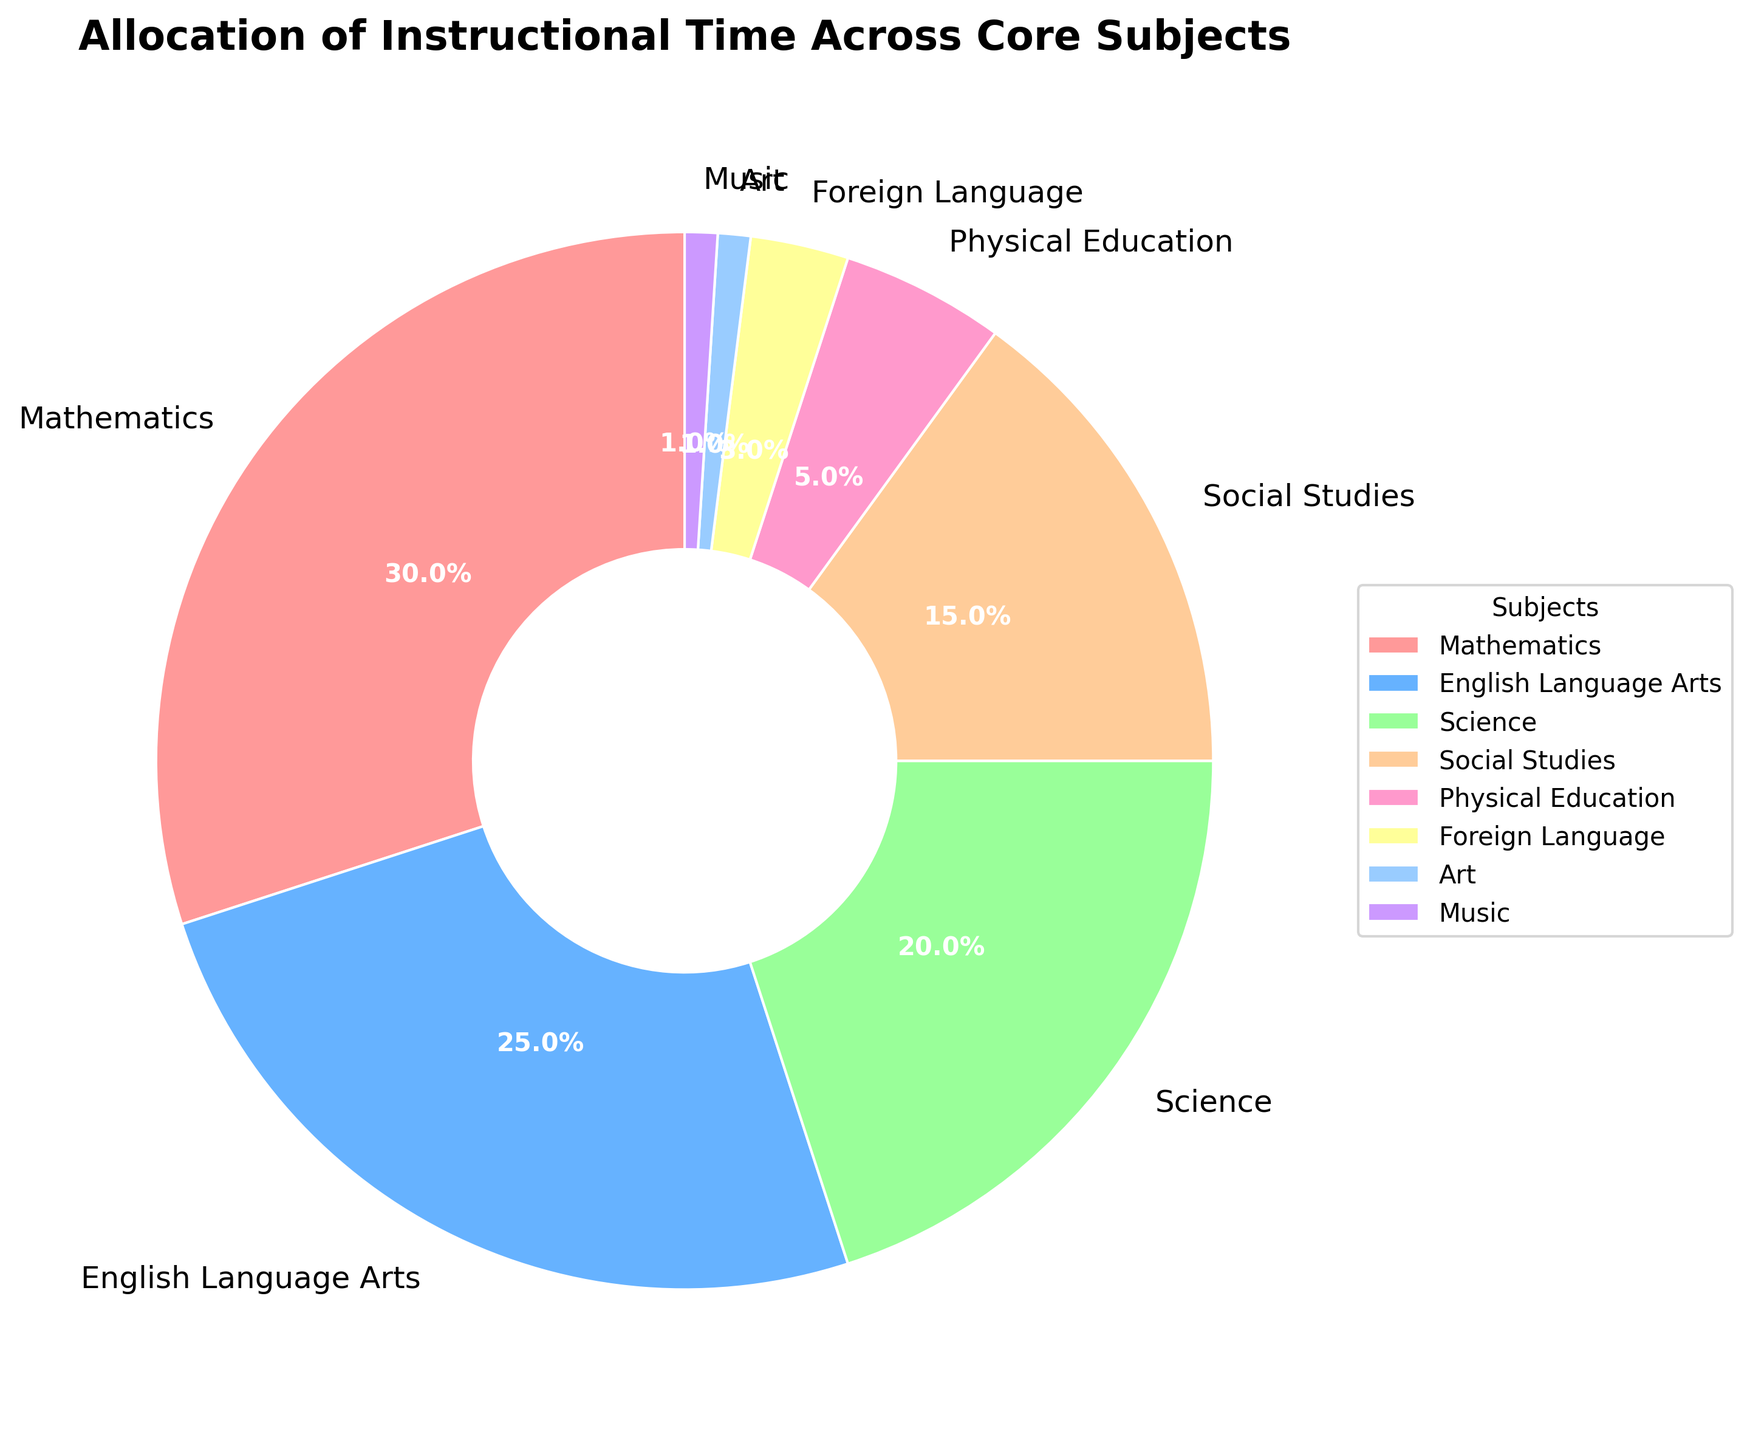What subject has the largest allocation of instructional time? The pie chart shows that Mathematics has the largest section, indicated by a larger wedge compared to others.
Answer: Mathematics What is the total percentage allocated to Physical Education, Foreign Language, Art, and Music combined? To find the total, sum the individual percentages: Physical Education (5%) + Foreign Language (3%) + Art (1%) + Music (1%) = 10%.
Answer: 10% How does the percentage allocated to Science compare to the percentage allocated to Social Studies? The pie chart shows Science is allocated 20% and Social Studies 15%. Comparing these, Science has a higher percentage.
Answer: Science has a higher percentage What percentage of time is allocated to subjects other than Mathematics and English Language Arts? Subtract the percentages of Mathematics and English Language Arts from 100%: 100% - (30% + 25%) = 45%.
Answer: 45% Which subject is allocated more time, Foreign Language or Art? Comparing the wedges, Foreign Language has a percentage of 3% whereas Art has 1%. Foreign Language has a larger allocation.
Answer: Foreign Language Of the subjects presented, which ones have an allocation less than 10%? According to the pie chart, the subjects with allocations less than 10% are Physical Education (5%), Foreign Language (3%), Art (1%), and Music (1%).
Answer: Physical Education, Foreign Language, Art, Music By how much does the time allocated to Science exceed the time allocated to Foreign Language? The time allocated to Science is 20% while Foreign Language is 3%. The difference is 20% - 3% = 17%.
Answer: 17% If the percentages for Social Studies and Physical Education were combined, would their total exceed the percentage for Science? Combining Social Studies (15%) and Physical Education (5%) gives 15% + 5% = 20%, which is equal to the percentage for Science.
Answer: No Is the allocation for Physical Education higher than any one of the subjects in the Music and Art category? The pie chart shows that Physical Education is allocated 5%, while both Music and Art are allocated 1% each. Therefore, Physical Education is higher than both.
Answer: Yes What is the difference in allocation time between the subject with the highest percentage and the subject with the lowest percentage? Mathematics has the highest allocation with 30% and both Art and Music have the lowest with 1% each. The difference is 30% - 1% = 29%.
Answer: 29% 